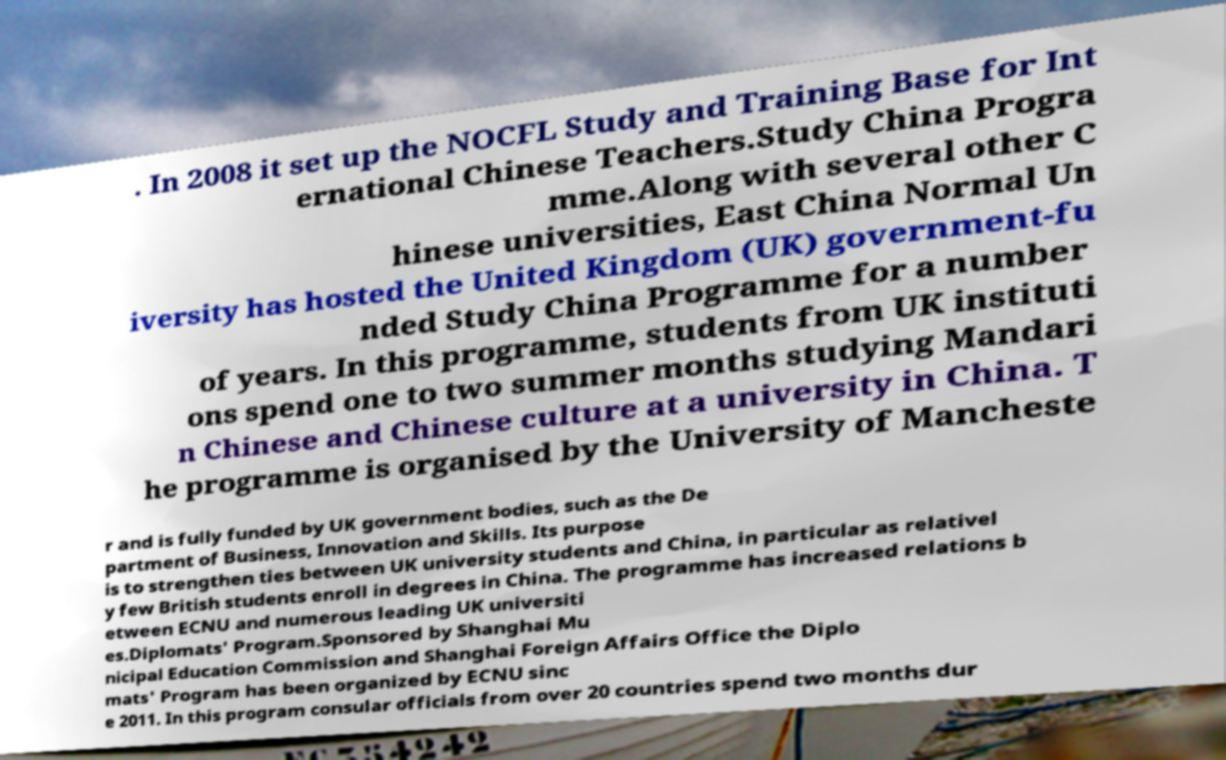There's text embedded in this image that I need extracted. Can you transcribe it verbatim? . In 2008 it set up the NOCFL Study and Training Base for Int ernational Chinese Teachers.Study China Progra mme.Along with several other C hinese universities, East China Normal Un iversity has hosted the United Kingdom (UK) government-fu nded Study China Programme for a number of years. In this programme, students from UK instituti ons spend one to two summer months studying Mandari n Chinese and Chinese culture at a university in China. T he programme is organised by the University of Mancheste r and is fully funded by UK government bodies, such as the De partment of Business, Innovation and Skills. Its purpose is to strengthen ties between UK university students and China, in particular as relativel y few British students enroll in degrees in China. The programme has increased relations b etween ECNU and numerous leading UK universiti es.Diplomats' Program.Sponsored by Shanghai Mu nicipal Education Commission and Shanghai Foreign Affairs Office the Diplo mats' Program has been organized by ECNU sinc e 2011. In this program consular officials from over 20 countries spend two months dur 